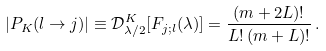Convert formula to latex. <formula><loc_0><loc_0><loc_500><loc_500>| P _ { K } ( l \rightarrow j ) | \equiv \mathcal { D } ^ { K } _ { \lambda / 2 } [ F _ { j ; l } ( { \lambda } ) ] = \frac { ( m + 2 L ) ! } { L ! \, ( m + L ) ! } \, .</formula> 